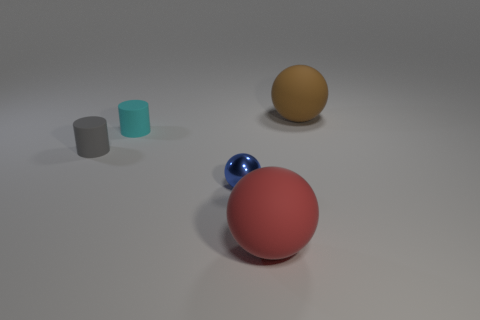Subtract all gray cylinders. Subtract all cyan blocks. How many cylinders are left? 1 Add 3 brown balls. How many objects exist? 8 Subtract all cylinders. How many objects are left? 3 Subtract 0 green cylinders. How many objects are left? 5 Subtract all big gray blocks. Subtract all small things. How many objects are left? 2 Add 1 small cyan rubber objects. How many small cyan rubber objects are left? 2 Add 1 blue rubber blocks. How many blue rubber blocks exist? 1 